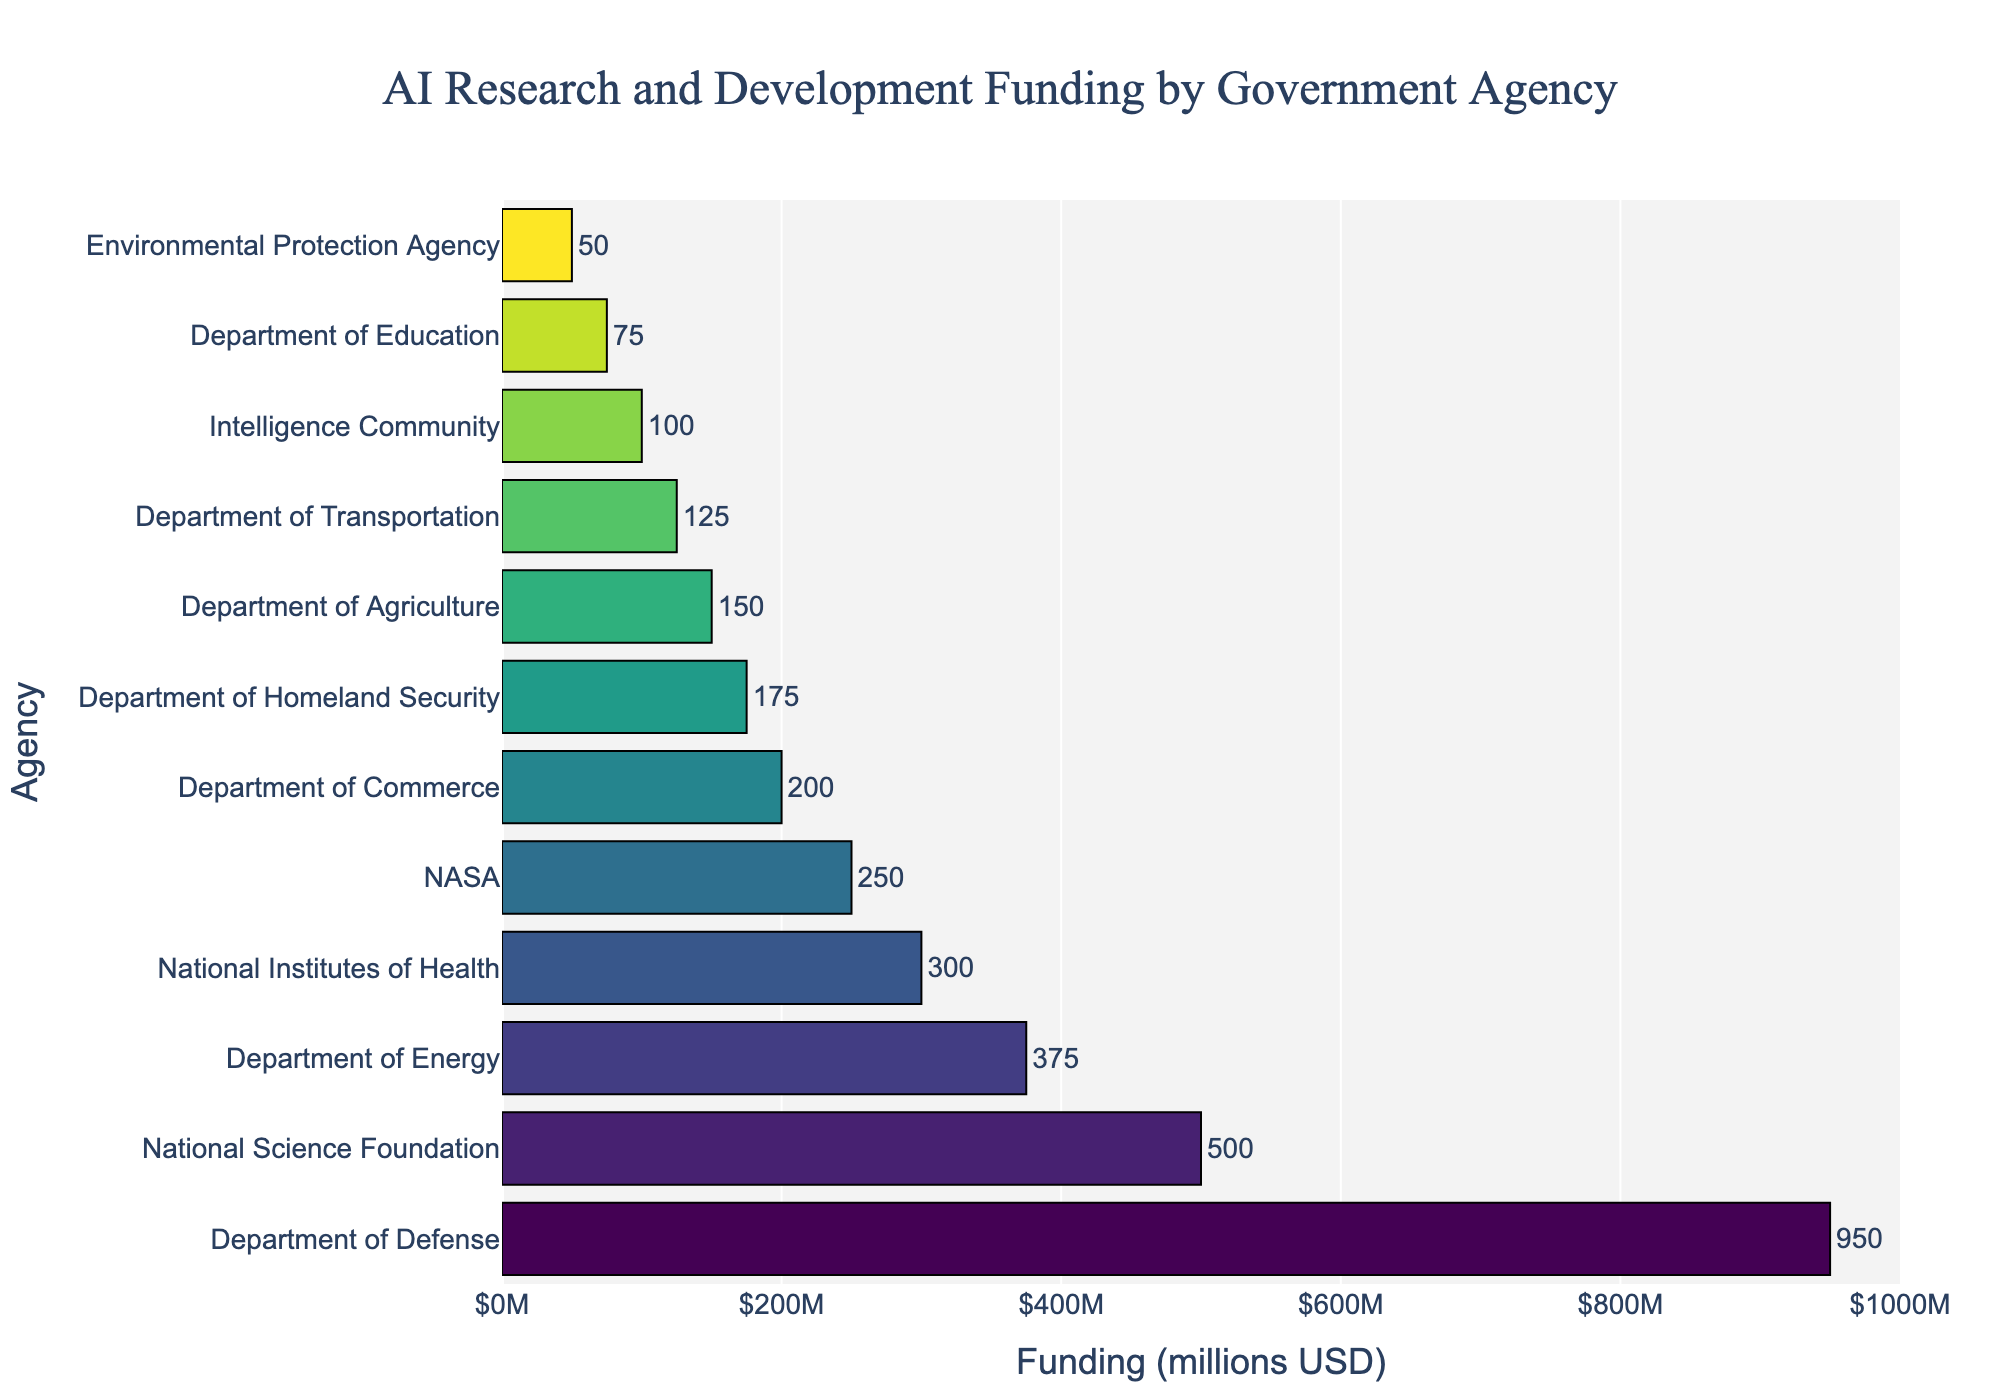What is the agency with the highest funding for AI research and development? The agency with the highest funding is at the top of the sorted list of agencies by funding amount. In the figure, the Department of Defense is at the top with $950 million allocated.
Answer: Department of Defense What is the total funding allocated to the top three agencies combined? To find the total funding for the top three agencies, sum their individual funding amounts: Department of Defense ($950M) + National Science Foundation ($500M) + Department of Energy ($375M). Thus, the total is $950 + $500 + $375.
Answer: $1825 million How much more funding does the National Science Foundation receive compared to NASA? To find the difference in funding, subtract NASA's funding amount from the National Science Foundation's funding: $500M (NSF) - $250M (NASA).
Answer: $250 million Which agencies received funding amounts less than $200 million? Locate all agencies whose bars extend less than $200 million on the x-axis. These agencies are the Department of Commerce ($200M), Department of Homeland Security ($175M), Department of Agriculture ($150M), Department of Transportation ($125M), Intelligence Community ($100M), Department of Education ($75M), and Environmental Protection Agency ($50M).
Answer: Department of Commerce, Department of Homeland Security, Department of Agriculture, Department of Transportation, Intelligence Community, Department of Education, Environmental Protection Agency What is the average funding allocated across all agencies? To find the average funding, sum the funding amounts of all listed agencies and divide by the number of agencies. The total funding is $950M + $500M + $375M + $300M + $250M + $200M + $175M + $150M + $125M + $100M + $75M + $50M = $3250 million. There are 12 agencies, so the average is $3250 million / 12.
Answer: $270.83 million How does the funding for the National Institutes of Health compare to the Environmental Protection Agency? To compare, observe that the funding for the National Institutes of Health ($300M) is significantly higher than the funding for the Environmental Protection Agency ($50M).
Answer: NIH has $250 million more than EPA What is the median funding amount among all agencies? To determine the median funding, list all funding amounts in ascending order: $50M, $75M, $100M, $125M, $150M, $175M, $200M, $250M, $300M, $375M, $500M, $950M. The median is the middle value. With 12 values, the median is the average of the 6th and 7th values: ($175M + $200M) / 2.
Answer: $187.5 million What are the colors used for the top three agencies' bars? The top three agencies (Department of Defense, National Science Foundation, and Department of Energy) likely appear in the first three shades of the Viridis color scale, ranging from dark to light shades. Their exact colors would not be named in the figure, but they are distinguishable along a gradient.
Answer: Dark to light Viridis shades How does the funding for the Intelligence Community compare to the Department of Education? Compare the funding amounts; the Intelligence Community receives $100M while the Department of Education receives $75M. Therefore, the Intelligence Community receives $25M more.
Answer: $25 million more Which agency has the bar with the smallest length, indicating the least funding? The bar corresponding to the smallest funding amount appears shortest. The Environmental Protection Agency, with $50 million, has the smallest bar length.
Answer: Environmental Protection Agency 